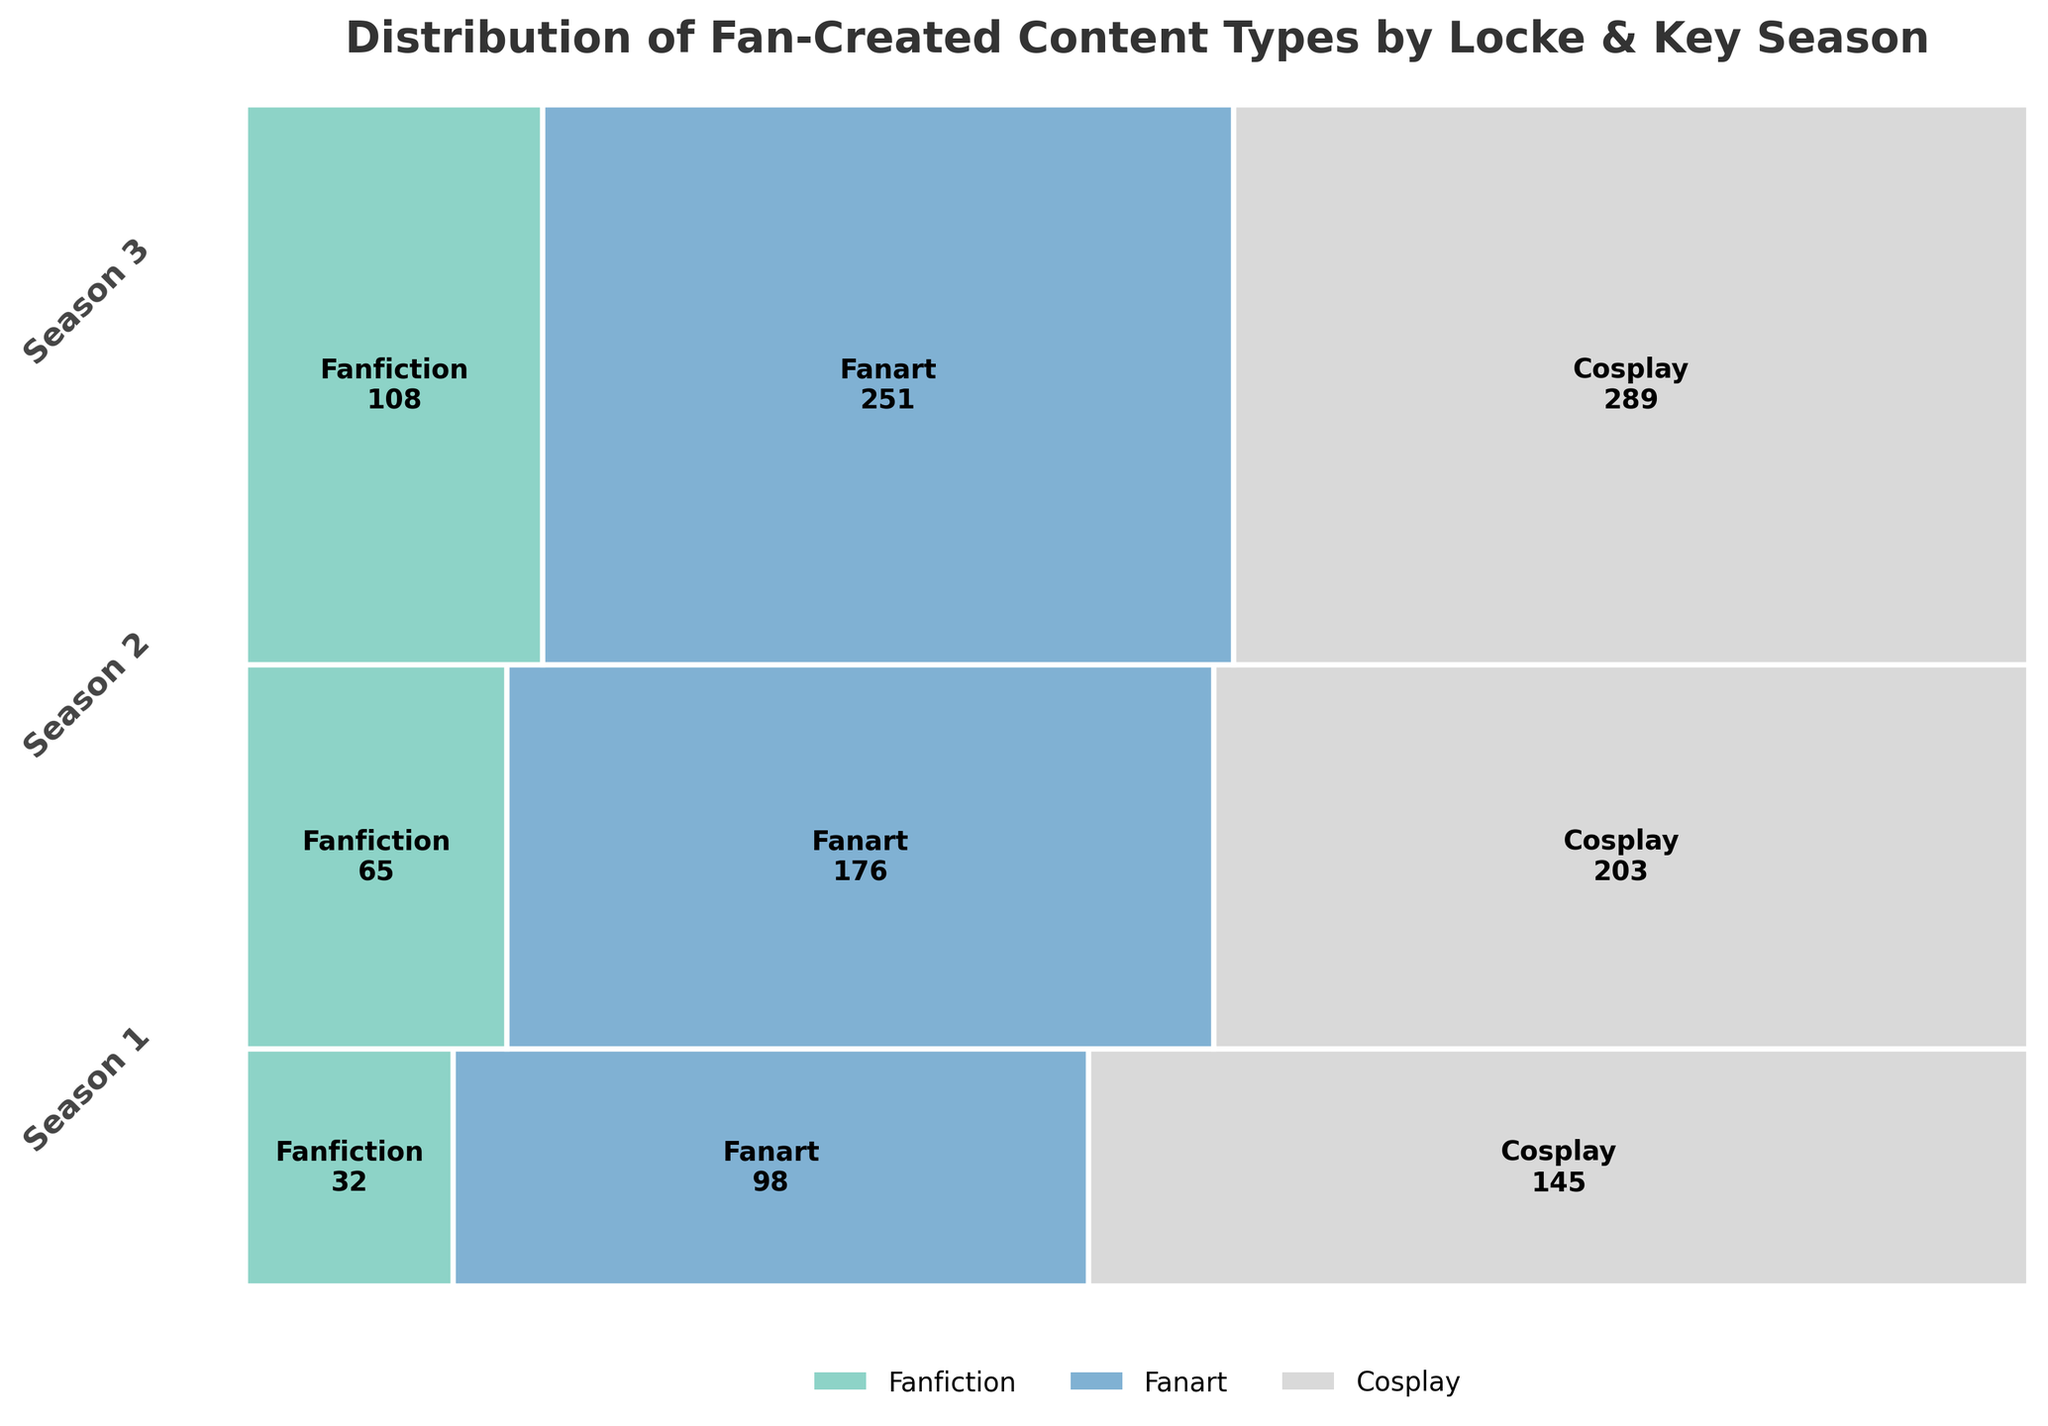How many fan-created cosplays are there in Season 3? The rectangle corresponding to cosplay in Season 3 is labeled with the count 108.
Answer: 108 Which season has the highest total fan-created content? Season 3 appears to have the largest overall height in the plot, indicating the highest total fan-created content.
Answer: Season 3 What percentage of fan-created content in Season 2 is fanfiction? In Season 2, the width of the fanfiction section is visually about half. The exact count for fanfiction is 203, and the total for Season 2 is 203 + 176 + 65 = 444. The percentage is (203/444) * 100%.
Answer: ~45.7% Which content type grew the most from Season 1 to Season 3? Comparing the counts for each content type from Season 1 to Season 3, fanfiction grew from 145 to 289, fanart from 98 to 251, and cosplay from 32 to 108. The absolute increases are measured, with fanart having the highest increase (251 - 98 = 153).
Answer: Fanart How much more fanart is created in Season 3 compared to Season 1? Season 3 fanart count is 251 and Season 1 fanart count is 98. The difference is 251 - 98.
Answer: 153 What is the total amount of fan-created content for all seasons combined? Sum the total counts for each season: (145 + 98 + 32) + (203 + 176 + 65) + (289 + 251 + 108).
Answer: 1367 In which season does cosplay take up the smallest proportion of content? By visually inspecting the widths, Season 1 has the narrowest segment for cosplay.
Answer: Season 1 What is the relative difference in fanfiction counts between Season 2 and Season 3? The fanfiction counts are 203 for Season 2 and 289 for Season 3. The relative difference is calculated as (289 - 203) / 203 * 100%.
Answer: ~42.4% Between which two consecutive seasons was the increase in fanfiction counts the greatest? The fanfiction counts are 145 for Season 1, 203 for Season 2, and 289 for Season 3. The increase from Season 1 to Season 2 is 203 - 145 = 58 and from Season 2 to Season 3 is 289 - 203 = 86.
Answer: Between Season 2 and Season 3 Which content type is consistently the least across all three seasons? Cosplay has the smallest segment width across all seasons visually.
Answer: Cosplay 